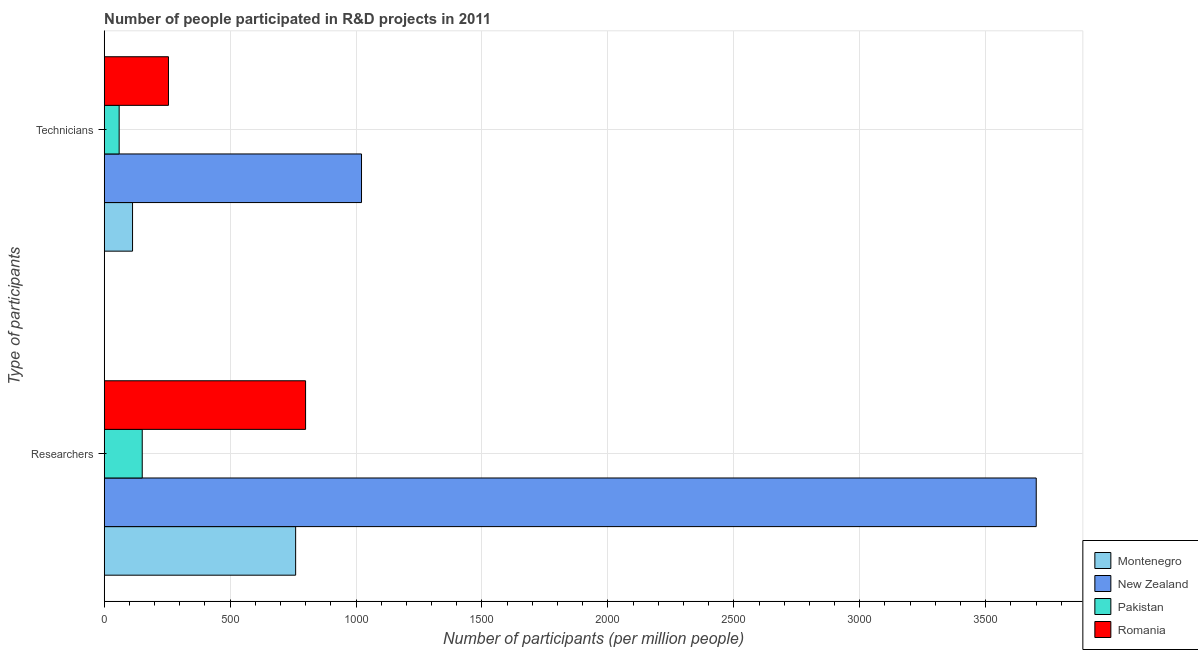How many different coloured bars are there?
Your response must be concise. 4. Are the number of bars per tick equal to the number of legend labels?
Provide a succinct answer. Yes. Are the number of bars on each tick of the Y-axis equal?
Provide a succinct answer. Yes. How many bars are there on the 2nd tick from the bottom?
Ensure brevity in your answer.  4. What is the label of the 1st group of bars from the top?
Ensure brevity in your answer.  Technicians. What is the number of technicians in Montenegro?
Your response must be concise. 112.53. Across all countries, what is the maximum number of technicians?
Offer a very short reply. 1021.69. Across all countries, what is the minimum number of researchers?
Offer a very short reply. 150.99. In which country was the number of technicians maximum?
Your response must be concise. New Zealand. In which country was the number of researchers minimum?
Make the answer very short. Pakistan. What is the total number of researchers in the graph?
Your answer should be compact. 5411.39. What is the difference between the number of researchers in Pakistan and that in Montenegro?
Your answer should be very brief. -609.09. What is the difference between the number of technicians in New Zealand and the number of researchers in Pakistan?
Give a very brief answer. 870.69. What is the average number of researchers per country?
Your answer should be very brief. 1352.85. What is the difference between the number of technicians and number of researchers in Montenegro?
Your answer should be very brief. -647.56. In how many countries, is the number of technicians greater than 100 ?
Offer a very short reply. 3. What is the ratio of the number of technicians in New Zealand to that in Pakistan?
Offer a very short reply. 17.22. In how many countries, is the number of technicians greater than the average number of technicians taken over all countries?
Ensure brevity in your answer.  1. What does the 3rd bar from the top in Technicians represents?
Provide a short and direct response. New Zealand. What does the 4th bar from the bottom in Researchers represents?
Provide a succinct answer. Romania. How many bars are there?
Offer a terse response. 8. Are all the bars in the graph horizontal?
Ensure brevity in your answer.  Yes. How many countries are there in the graph?
Ensure brevity in your answer.  4. Are the values on the major ticks of X-axis written in scientific E-notation?
Give a very brief answer. No. Does the graph contain grids?
Your response must be concise. Yes. Where does the legend appear in the graph?
Give a very brief answer. Bottom right. How many legend labels are there?
Provide a succinct answer. 4. How are the legend labels stacked?
Your answer should be compact. Vertical. What is the title of the graph?
Your response must be concise. Number of people participated in R&D projects in 2011. What is the label or title of the X-axis?
Provide a short and direct response. Number of participants (per million people). What is the label or title of the Y-axis?
Give a very brief answer. Type of participants. What is the Number of participants (per million people) in Montenegro in Researchers?
Your response must be concise. 760.08. What is the Number of participants (per million people) in New Zealand in Researchers?
Offer a terse response. 3700.77. What is the Number of participants (per million people) of Pakistan in Researchers?
Offer a very short reply. 150.99. What is the Number of participants (per million people) in Romania in Researchers?
Provide a short and direct response. 799.54. What is the Number of participants (per million people) of Montenegro in Technicians?
Your response must be concise. 112.53. What is the Number of participants (per million people) of New Zealand in Technicians?
Make the answer very short. 1021.69. What is the Number of participants (per million people) in Pakistan in Technicians?
Make the answer very short. 59.33. What is the Number of participants (per million people) in Romania in Technicians?
Offer a very short reply. 255.18. Across all Type of participants, what is the maximum Number of participants (per million people) of Montenegro?
Provide a succinct answer. 760.08. Across all Type of participants, what is the maximum Number of participants (per million people) in New Zealand?
Your response must be concise. 3700.77. Across all Type of participants, what is the maximum Number of participants (per million people) in Pakistan?
Your answer should be compact. 150.99. Across all Type of participants, what is the maximum Number of participants (per million people) of Romania?
Provide a succinct answer. 799.54. Across all Type of participants, what is the minimum Number of participants (per million people) of Montenegro?
Your response must be concise. 112.53. Across all Type of participants, what is the minimum Number of participants (per million people) in New Zealand?
Give a very brief answer. 1021.69. Across all Type of participants, what is the minimum Number of participants (per million people) in Pakistan?
Your response must be concise. 59.33. Across all Type of participants, what is the minimum Number of participants (per million people) in Romania?
Ensure brevity in your answer.  255.18. What is the total Number of participants (per million people) of Montenegro in the graph?
Keep it short and to the point. 872.61. What is the total Number of participants (per million people) in New Zealand in the graph?
Offer a very short reply. 4722.46. What is the total Number of participants (per million people) in Pakistan in the graph?
Your response must be concise. 210.32. What is the total Number of participants (per million people) in Romania in the graph?
Offer a terse response. 1054.71. What is the difference between the Number of participants (per million people) in Montenegro in Researchers and that in Technicians?
Your answer should be compact. 647.56. What is the difference between the Number of participants (per million people) of New Zealand in Researchers and that in Technicians?
Keep it short and to the point. 2679.09. What is the difference between the Number of participants (per million people) of Pakistan in Researchers and that in Technicians?
Offer a very short reply. 91.66. What is the difference between the Number of participants (per million people) in Romania in Researchers and that in Technicians?
Your answer should be very brief. 544.36. What is the difference between the Number of participants (per million people) of Montenegro in Researchers and the Number of participants (per million people) of New Zealand in Technicians?
Your response must be concise. -261.6. What is the difference between the Number of participants (per million people) in Montenegro in Researchers and the Number of participants (per million people) in Pakistan in Technicians?
Keep it short and to the point. 700.75. What is the difference between the Number of participants (per million people) in Montenegro in Researchers and the Number of participants (per million people) in Romania in Technicians?
Your answer should be very brief. 504.91. What is the difference between the Number of participants (per million people) of New Zealand in Researchers and the Number of participants (per million people) of Pakistan in Technicians?
Make the answer very short. 3641.44. What is the difference between the Number of participants (per million people) of New Zealand in Researchers and the Number of participants (per million people) of Romania in Technicians?
Offer a terse response. 3445.6. What is the difference between the Number of participants (per million people) in Pakistan in Researchers and the Number of participants (per million people) in Romania in Technicians?
Make the answer very short. -104.18. What is the average Number of participants (per million people) in Montenegro per Type of participants?
Offer a terse response. 436.31. What is the average Number of participants (per million people) of New Zealand per Type of participants?
Provide a short and direct response. 2361.23. What is the average Number of participants (per million people) of Pakistan per Type of participants?
Make the answer very short. 105.16. What is the average Number of participants (per million people) in Romania per Type of participants?
Offer a very short reply. 527.36. What is the difference between the Number of participants (per million people) in Montenegro and Number of participants (per million people) in New Zealand in Researchers?
Offer a very short reply. -2940.69. What is the difference between the Number of participants (per million people) in Montenegro and Number of participants (per million people) in Pakistan in Researchers?
Offer a very short reply. 609.09. What is the difference between the Number of participants (per million people) in Montenegro and Number of participants (per million people) in Romania in Researchers?
Give a very brief answer. -39.45. What is the difference between the Number of participants (per million people) of New Zealand and Number of participants (per million people) of Pakistan in Researchers?
Keep it short and to the point. 3549.78. What is the difference between the Number of participants (per million people) of New Zealand and Number of participants (per million people) of Romania in Researchers?
Provide a short and direct response. 2901.24. What is the difference between the Number of participants (per million people) in Pakistan and Number of participants (per million people) in Romania in Researchers?
Give a very brief answer. -648.54. What is the difference between the Number of participants (per million people) of Montenegro and Number of participants (per million people) of New Zealand in Technicians?
Keep it short and to the point. -909.16. What is the difference between the Number of participants (per million people) of Montenegro and Number of participants (per million people) of Pakistan in Technicians?
Your answer should be very brief. 53.2. What is the difference between the Number of participants (per million people) in Montenegro and Number of participants (per million people) in Romania in Technicians?
Give a very brief answer. -142.65. What is the difference between the Number of participants (per million people) in New Zealand and Number of participants (per million people) in Pakistan in Technicians?
Ensure brevity in your answer.  962.36. What is the difference between the Number of participants (per million people) of New Zealand and Number of participants (per million people) of Romania in Technicians?
Give a very brief answer. 766.51. What is the difference between the Number of participants (per million people) in Pakistan and Number of participants (per million people) in Romania in Technicians?
Your answer should be very brief. -195.84. What is the ratio of the Number of participants (per million people) of Montenegro in Researchers to that in Technicians?
Ensure brevity in your answer.  6.75. What is the ratio of the Number of participants (per million people) of New Zealand in Researchers to that in Technicians?
Your answer should be compact. 3.62. What is the ratio of the Number of participants (per million people) in Pakistan in Researchers to that in Technicians?
Your response must be concise. 2.54. What is the ratio of the Number of participants (per million people) of Romania in Researchers to that in Technicians?
Keep it short and to the point. 3.13. What is the difference between the highest and the second highest Number of participants (per million people) in Montenegro?
Your response must be concise. 647.56. What is the difference between the highest and the second highest Number of participants (per million people) in New Zealand?
Offer a terse response. 2679.09. What is the difference between the highest and the second highest Number of participants (per million people) of Pakistan?
Provide a short and direct response. 91.66. What is the difference between the highest and the second highest Number of participants (per million people) in Romania?
Keep it short and to the point. 544.36. What is the difference between the highest and the lowest Number of participants (per million people) in Montenegro?
Provide a succinct answer. 647.56. What is the difference between the highest and the lowest Number of participants (per million people) in New Zealand?
Offer a very short reply. 2679.09. What is the difference between the highest and the lowest Number of participants (per million people) of Pakistan?
Make the answer very short. 91.66. What is the difference between the highest and the lowest Number of participants (per million people) in Romania?
Ensure brevity in your answer.  544.36. 